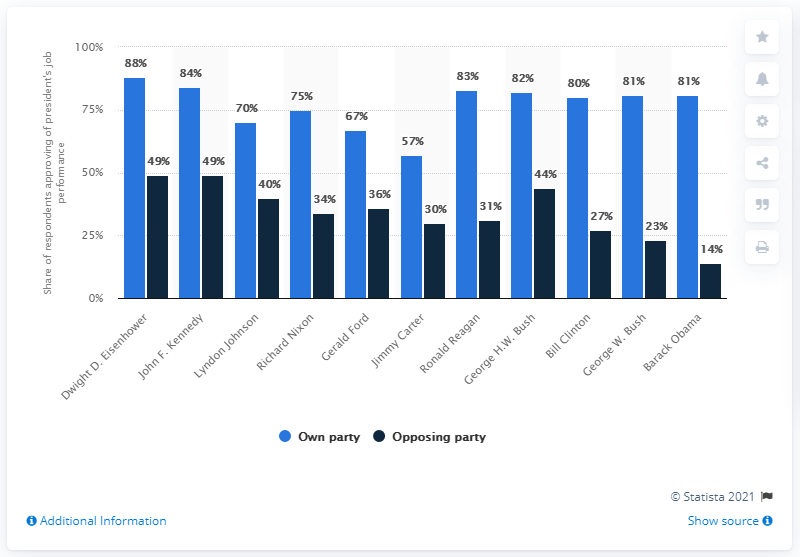Mention a couple of crucial points in this snapshot. Bill Clinton, with a value of 80% in his own party and 27% in the opposing party, is considered a strong leader. President Dwight D. Eisenhower and President John F. Kennedy received more than 45% of their overall score from their opposition party during their respective presidencies. 